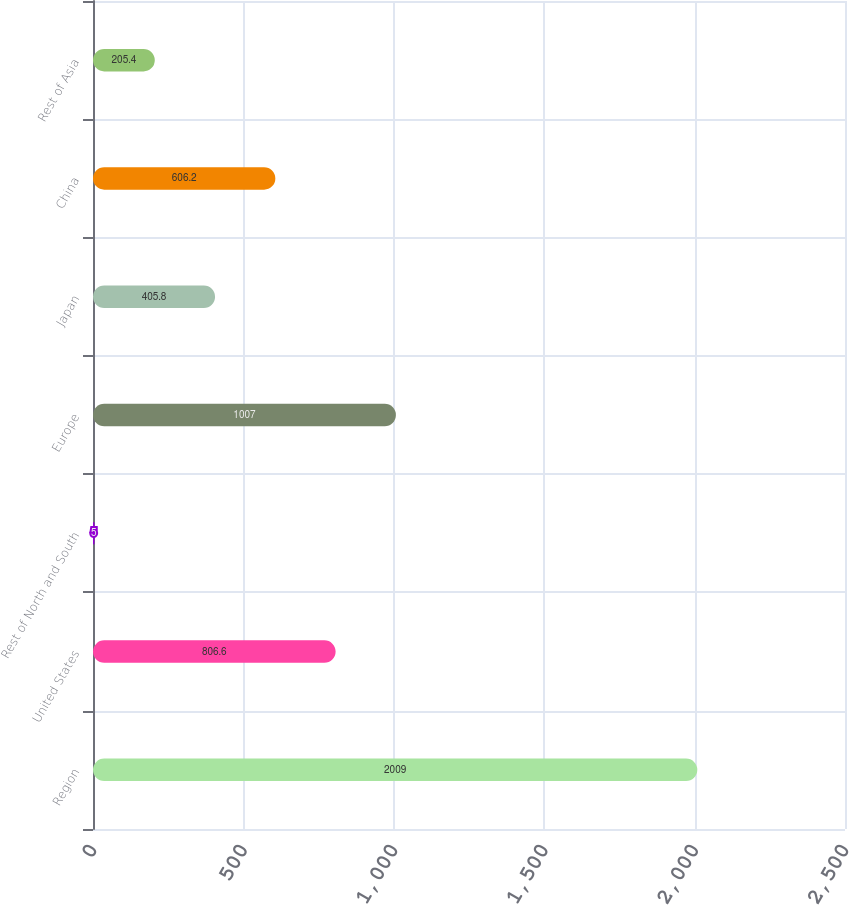Convert chart to OTSL. <chart><loc_0><loc_0><loc_500><loc_500><bar_chart><fcel>Region<fcel>United States<fcel>Rest of North and South<fcel>Europe<fcel>Japan<fcel>China<fcel>Rest of Asia<nl><fcel>2009<fcel>806.6<fcel>5<fcel>1007<fcel>405.8<fcel>606.2<fcel>205.4<nl></chart> 